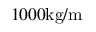Convert formula to latex. <formula><loc_0><loc_0><loc_500><loc_500>1 0 0 0 k g / m</formula> 